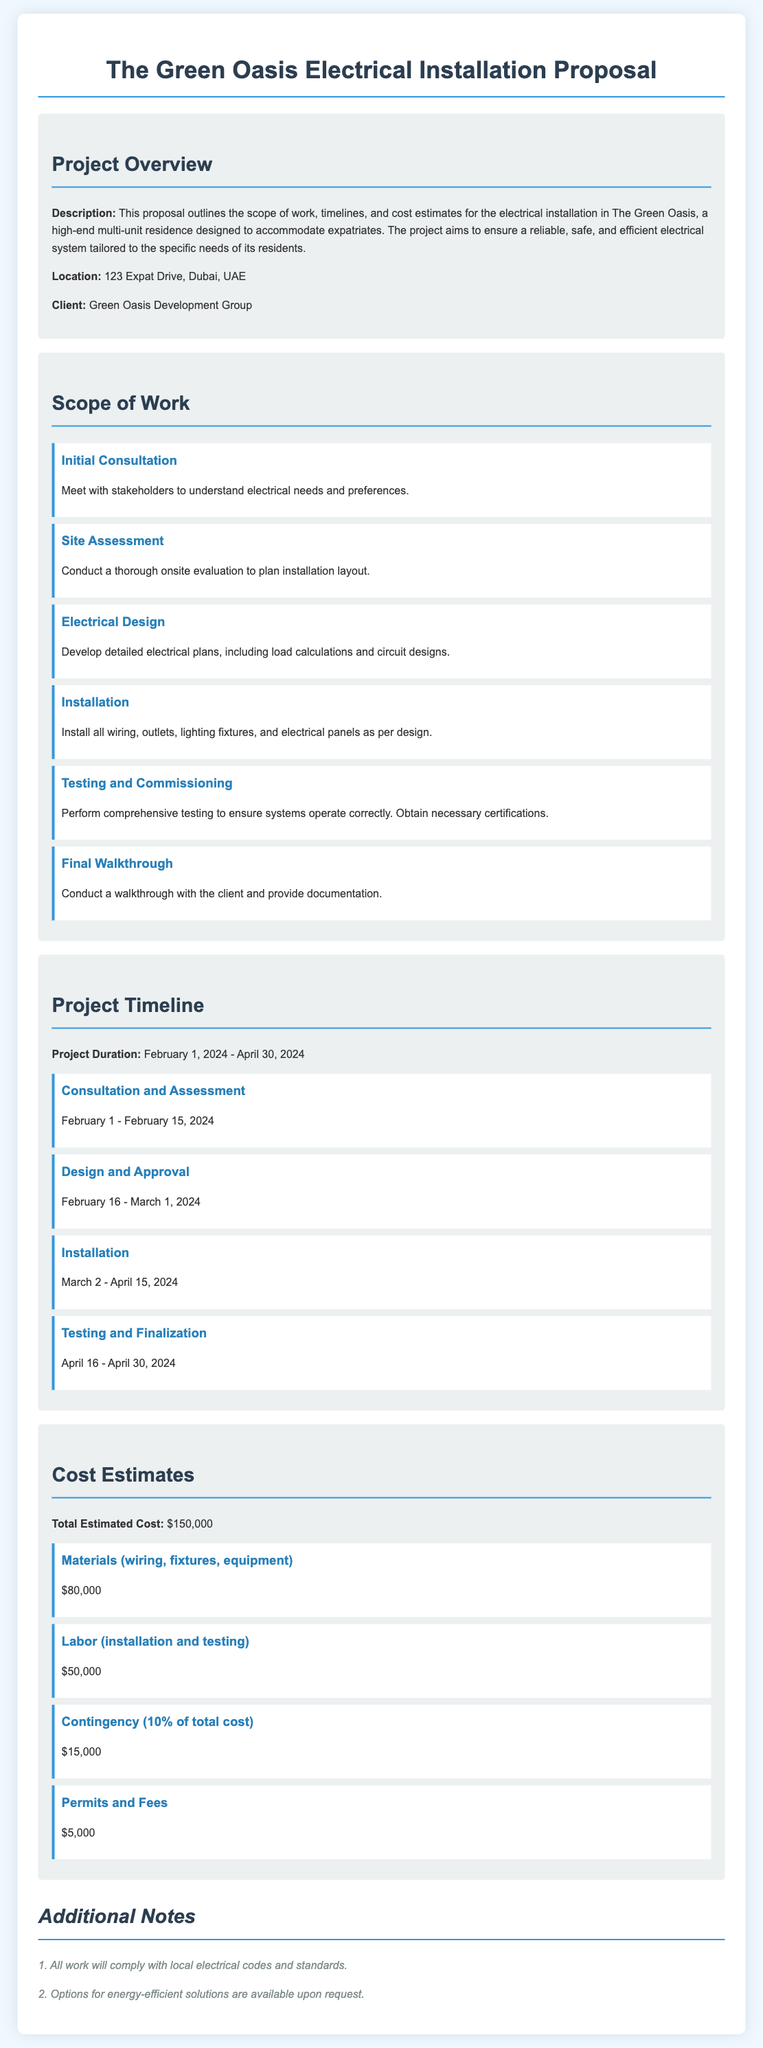What is the project location? The project location is specified in the overview section of the document.
Answer: 123 Expat Drive, Dubai, UAE Who is the client? The client information is mentioned in the project overview.
Answer: Green Oasis Development Group What is the total estimated cost? The total estimated cost is listed under the cost estimates section.
Answer: $150,000 What is the duration of the project? The project duration is provided in the timeline section.
Answer: February 1, 2024 - April 30, 2024 What phase comes after "Consultation and Assessment"? The timeline lists the phases in order, allowing us to deduce the sequence of work.
Answer: Design and Approval How much is allocated for materials? The cost estimates provide a breakdown of expenses, including materials.
Answer: $80,000 What is one of the additional notes? The additional notes section includes specific notes that provide more context about the project.
Answer: All work will comply with local electrical codes and standards What task involves meeting stakeholders? The scope of work describes each task, including initial meetings.
Answer: Initial Consultation How many tasks are listed in the scope of work? The scope of work describes each task separately, allowing us to count them.
Answer: 6 